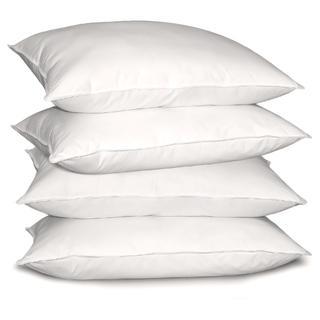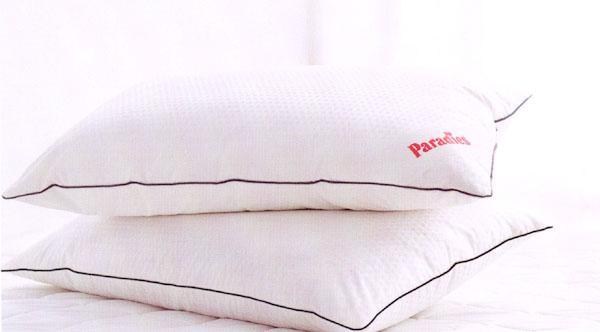The first image is the image on the left, the second image is the image on the right. For the images shown, is this caption "There are two stacks of three pillows." true? Answer yes or no. No. The first image is the image on the left, the second image is the image on the right. Analyze the images presented: Is the assertion "Left and right images each contain exactly three white pillows arranged in a vertical stack." valid? Answer yes or no. No. 